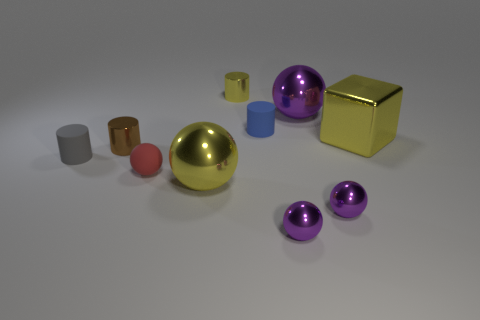How many purple spheres must be subtracted to get 1 purple spheres? 2 Subtract all tiny purple balls. How many balls are left? 3 Subtract all yellow balls. How many balls are left? 4 Subtract all cylinders. How many objects are left? 6 Subtract 2 cylinders. How many cylinders are left? 2 Add 6 small blue matte objects. How many small blue matte objects exist? 7 Subtract 0 red cylinders. How many objects are left? 10 Subtract all brown balls. Subtract all purple cylinders. How many balls are left? 5 Subtract all cyan cubes. How many yellow cylinders are left? 1 Subtract all small spheres. Subtract all tiny cyan balls. How many objects are left? 7 